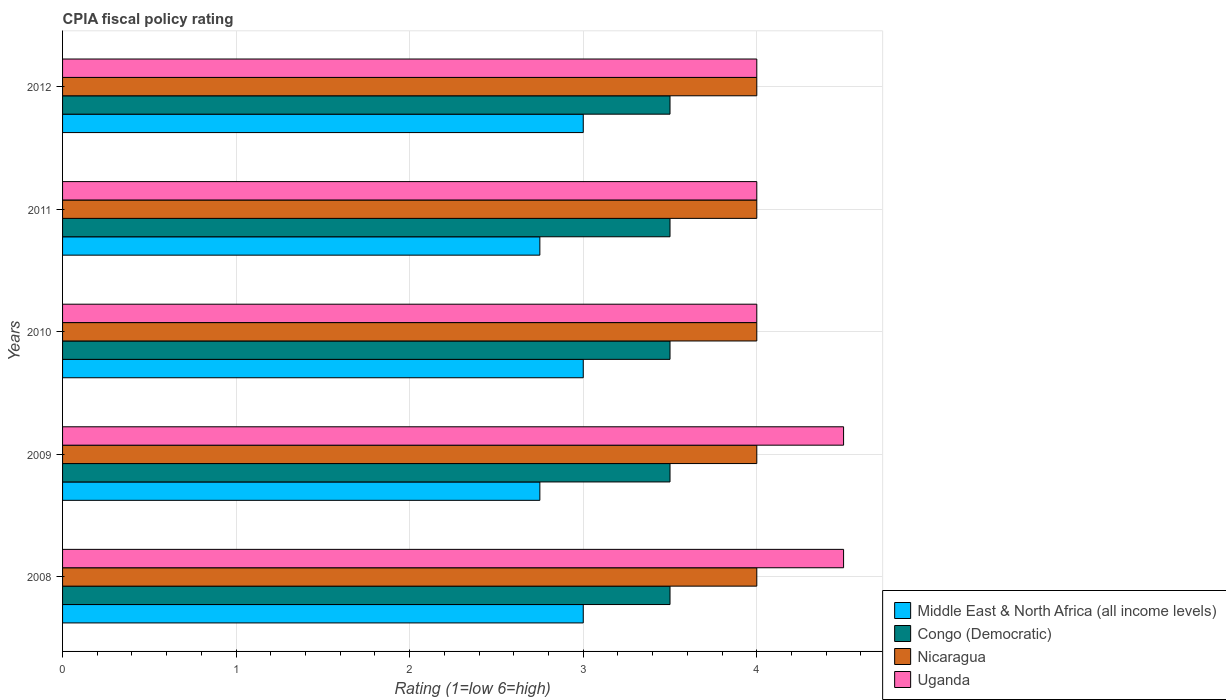How many different coloured bars are there?
Keep it short and to the point. 4. How many groups of bars are there?
Provide a succinct answer. 5. Are the number of bars per tick equal to the number of legend labels?
Keep it short and to the point. Yes. Are the number of bars on each tick of the Y-axis equal?
Your answer should be very brief. Yes. How many bars are there on the 5th tick from the top?
Make the answer very short. 4. What is the label of the 1st group of bars from the top?
Provide a short and direct response. 2012. What is the CPIA rating in Middle East & North Africa (all income levels) in 2009?
Make the answer very short. 2.75. Across all years, what is the maximum CPIA rating in Uganda?
Give a very brief answer. 4.5. What is the total CPIA rating in Nicaragua in the graph?
Your response must be concise. 20. What is the difference between the CPIA rating in Uganda in 2009 and that in 2012?
Your answer should be very brief. 0.5. What is the difference between the CPIA rating in Congo (Democratic) in 2011 and the CPIA rating in Nicaragua in 2008?
Provide a short and direct response. -0.5. What is the average CPIA rating in Middle East & North Africa (all income levels) per year?
Offer a terse response. 2.9. In the year 2010, what is the difference between the CPIA rating in Nicaragua and CPIA rating in Uganda?
Offer a terse response. 0. What is the ratio of the CPIA rating in Nicaragua in 2009 to that in 2012?
Provide a succinct answer. 1. What is the difference between the highest and the second highest CPIA rating in Uganda?
Your answer should be very brief. 0. What is the difference between the highest and the lowest CPIA rating in Uganda?
Your response must be concise. 0.5. What does the 2nd bar from the top in 2009 represents?
Give a very brief answer. Nicaragua. What does the 2nd bar from the bottom in 2008 represents?
Your response must be concise. Congo (Democratic). How many bars are there?
Give a very brief answer. 20. How many years are there in the graph?
Offer a very short reply. 5. Are the values on the major ticks of X-axis written in scientific E-notation?
Offer a very short reply. No. Does the graph contain any zero values?
Give a very brief answer. No. How are the legend labels stacked?
Your answer should be very brief. Vertical. What is the title of the graph?
Provide a short and direct response. CPIA fiscal policy rating. What is the Rating (1=low 6=high) in Congo (Democratic) in 2008?
Keep it short and to the point. 3.5. What is the Rating (1=low 6=high) of Nicaragua in 2008?
Your answer should be compact. 4. What is the Rating (1=low 6=high) in Uganda in 2008?
Make the answer very short. 4.5. What is the Rating (1=low 6=high) of Middle East & North Africa (all income levels) in 2009?
Provide a short and direct response. 2.75. What is the Rating (1=low 6=high) in Nicaragua in 2009?
Your answer should be very brief. 4. What is the Rating (1=low 6=high) of Uganda in 2009?
Provide a succinct answer. 4.5. What is the Rating (1=low 6=high) in Congo (Democratic) in 2010?
Provide a succinct answer. 3.5. What is the Rating (1=low 6=high) in Nicaragua in 2010?
Give a very brief answer. 4. What is the Rating (1=low 6=high) of Uganda in 2010?
Your answer should be compact. 4. What is the Rating (1=low 6=high) of Middle East & North Africa (all income levels) in 2011?
Offer a very short reply. 2.75. What is the Rating (1=low 6=high) in Congo (Democratic) in 2011?
Give a very brief answer. 3.5. What is the Rating (1=low 6=high) in Nicaragua in 2011?
Provide a succinct answer. 4. What is the Rating (1=low 6=high) of Congo (Democratic) in 2012?
Provide a succinct answer. 3.5. What is the Rating (1=low 6=high) in Nicaragua in 2012?
Your response must be concise. 4. Across all years, what is the minimum Rating (1=low 6=high) of Middle East & North Africa (all income levels)?
Provide a succinct answer. 2.75. Across all years, what is the minimum Rating (1=low 6=high) in Congo (Democratic)?
Give a very brief answer. 3.5. Across all years, what is the minimum Rating (1=low 6=high) of Nicaragua?
Offer a terse response. 4. Across all years, what is the minimum Rating (1=low 6=high) in Uganda?
Keep it short and to the point. 4. What is the total Rating (1=low 6=high) of Congo (Democratic) in the graph?
Provide a short and direct response. 17.5. What is the total Rating (1=low 6=high) in Nicaragua in the graph?
Your response must be concise. 20. What is the total Rating (1=low 6=high) in Uganda in the graph?
Your answer should be compact. 21. What is the difference between the Rating (1=low 6=high) in Nicaragua in 2008 and that in 2009?
Provide a short and direct response. 0. What is the difference between the Rating (1=low 6=high) in Uganda in 2008 and that in 2009?
Ensure brevity in your answer.  0. What is the difference between the Rating (1=low 6=high) of Congo (Democratic) in 2008 and that in 2010?
Your answer should be compact. 0. What is the difference between the Rating (1=low 6=high) of Middle East & North Africa (all income levels) in 2008 and that in 2011?
Keep it short and to the point. 0.25. What is the difference between the Rating (1=low 6=high) in Uganda in 2008 and that in 2011?
Give a very brief answer. 0.5. What is the difference between the Rating (1=low 6=high) in Congo (Democratic) in 2008 and that in 2012?
Ensure brevity in your answer.  0. What is the difference between the Rating (1=low 6=high) of Nicaragua in 2008 and that in 2012?
Offer a very short reply. 0. What is the difference between the Rating (1=low 6=high) of Middle East & North Africa (all income levels) in 2009 and that in 2010?
Your response must be concise. -0.25. What is the difference between the Rating (1=low 6=high) of Middle East & North Africa (all income levels) in 2009 and that in 2012?
Provide a short and direct response. -0.25. What is the difference between the Rating (1=low 6=high) in Nicaragua in 2009 and that in 2012?
Give a very brief answer. 0. What is the difference between the Rating (1=low 6=high) of Middle East & North Africa (all income levels) in 2010 and that in 2011?
Give a very brief answer. 0.25. What is the difference between the Rating (1=low 6=high) of Congo (Democratic) in 2010 and that in 2011?
Provide a short and direct response. 0. What is the difference between the Rating (1=low 6=high) of Nicaragua in 2010 and that in 2011?
Your answer should be very brief. 0. What is the difference between the Rating (1=low 6=high) of Uganda in 2010 and that in 2011?
Your answer should be very brief. 0. What is the difference between the Rating (1=low 6=high) of Nicaragua in 2010 and that in 2012?
Provide a succinct answer. 0. What is the difference between the Rating (1=low 6=high) of Uganda in 2010 and that in 2012?
Offer a terse response. 0. What is the difference between the Rating (1=low 6=high) in Uganda in 2011 and that in 2012?
Your response must be concise. 0. What is the difference between the Rating (1=low 6=high) of Middle East & North Africa (all income levels) in 2008 and the Rating (1=low 6=high) of Nicaragua in 2009?
Your answer should be compact. -1. What is the difference between the Rating (1=low 6=high) of Middle East & North Africa (all income levels) in 2008 and the Rating (1=low 6=high) of Uganda in 2009?
Your answer should be very brief. -1.5. What is the difference between the Rating (1=low 6=high) in Congo (Democratic) in 2008 and the Rating (1=low 6=high) in Nicaragua in 2009?
Provide a short and direct response. -0.5. What is the difference between the Rating (1=low 6=high) of Congo (Democratic) in 2008 and the Rating (1=low 6=high) of Uganda in 2009?
Offer a very short reply. -1. What is the difference between the Rating (1=low 6=high) in Middle East & North Africa (all income levels) in 2008 and the Rating (1=low 6=high) in Nicaragua in 2010?
Ensure brevity in your answer.  -1. What is the difference between the Rating (1=low 6=high) of Congo (Democratic) in 2008 and the Rating (1=low 6=high) of Uganda in 2010?
Your answer should be compact. -0.5. What is the difference between the Rating (1=low 6=high) of Nicaragua in 2008 and the Rating (1=low 6=high) of Uganda in 2010?
Your response must be concise. 0. What is the difference between the Rating (1=low 6=high) of Middle East & North Africa (all income levels) in 2008 and the Rating (1=low 6=high) of Uganda in 2011?
Keep it short and to the point. -1. What is the difference between the Rating (1=low 6=high) of Congo (Democratic) in 2008 and the Rating (1=low 6=high) of Uganda in 2011?
Your answer should be very brief. -0.5. What is the difference between the Rating (1=low 6=high) of Nicaragua in 2008 and the Rating (1=low 6=high) of Uganda in 2011?
Give a very brief answer. 0. What is the difference between the Rating (1=low 6=high) of Middle East & North Africa (all income levels) in 2008 and the Rating (1=low 6=high) of Congo (Democratic) in 2012?
Give a very brief answer. -0.5. What is the difference between the Rating (1=low 6=high) in Middle East & North Africa (all income levels) in 2008 and the Rating (1=low 6=high) in Nicaragua in 2012?
Offer a terse response. -1. What is the difference between the Rating (1=low 6=high) in Congo (Democratic) in 2008 and the Rating (1=low 6=high) in Uganda in 2012?
Keep it short and to the point. -0.5. What is the difference between the Rating (1=low 6=high) in Middle East & North Africa (all income levels) in 2009 and the Rating (1=low 6=high) in Congo (Democratic) in 2010?
Your answer should be very brief. -0.75. What is the difference between the Rating (1=low 6=high) in Middle East & North Africa (all income levels) in 2009 and the Rating (1=low 6=high) in Nicaragua in 2010?
Your answer should be very brief. -1.25. What is the difference between the Rating (1=low 6=high) of Middle East & North Africa (all income levels) in 2009 and the Rating (1=low 6=high) of Uganda in 2010?
Offer a very short reply. -1.25. What is the difference between the Rating (1=low 6=high) of Congo (Democratic) in 2009 and the Rating (1=low 6=high) of Nicaragua in 2010?
Give a very brief answer. -0.5. What is the difference between the Rating (1=low 6=high) of Nicaragua in 2009 and the Rating (1=low 6=high) of Uganda in 2010?
Your response must be concise. 0. What is the difference between the Rating (1=low 6=high) in Middle East & North Africa (all income levels) in 2009 and the Rating (1=low 6=high) in Congo (Democratic) in 2011?
Make the answer very short. -0.75. What is the difference between the Rating (1=low 6=high) of Middle East & North Africa (all income levels) in 2009 and the Rating (1=low 6=high) of Nicaragua in 2011?
Provide a succinct answer. -1.25. What is the difference between the Rating (1=low 6=high) of Middle East & North Africa (all income levels) in 2009 and the Rating (1=low 6=high) of Uganda in 2011?
Give a very brief answer. -1.25. What is the difference between the Rating (1=low 6=high) of Congo (Democratic) in 2009 and the Rating (1=low 6=high) of Nicaragua in 2011?
Your answer should be very brief. -0.5. What is the difference between the Rating (1=low 6=high) in Middle East & North Africa (all income levels) in 2009 and the Rating (1=low 6=high) in Congo (Democratic) in 2012?
Keep it short and to the point. -0.75. What is the difference between the Rating (1=low 6=high) of Middle East & North Africa (all income levels) in 2009 and the Rating (1=low 6=high) of Nicaragua in 2012?
Provide a short and direct response. -1.25. What is the difference between the Rating (1=low 6=high) in Middle East & North Africa (all income levels) in 2009 and the Rating (1=low 6=high) in Uganda in 2012?
Your answer should be compact. -1.25. What is the difference between the Rating (1=low 6=high) in Middle East & North Africa (all income levels) in 2010 and the Rating (1=low 6=high) in Nicaragua in 2011?
Keep it short and to the point. -1. What is the difference between the Rating (1=low 6=high) in Middle East & North Africa (all income levels) in 2010 and the Rating (1=low 6=high) in Uganda in 2011?
Make the answer very short. -1. What is the difference between the Rating (1=low 6=high) in Congo (Democratic) in 2010 and the Rating (1=low 6=high) in Nicaragua in 2011?
Your answer should be very brief. -0.5. What is the difference between the Rating (1=low 6=high) of Congo (Democratic) in 2010 and the Rating (1=low 6=high) of Uganda in 2011?
Your answer should be compact. -0.5. What is the difference between the Rating (1=low 6=high) of Nicaragua in 2010 and the Rating (1=low 6=high) of Uganda in 2011?
Provide a short and direct response. 0. What is the difference between the Rating (1=low 6=high) in Middle East & North Africa (all income levels) in 2010 and the Rating (1=low 6=high) in Congo (Democratic) in 2012?
Your response must be concise. -0.5. What is the difference between the Rating (1=low 6=high) in Middle East & North Africa (all income levels) in 2010 and the Rating (1=low 6=high) in Nicaragua in 2012?
Keep it short and to the point. -1. What is the difference between the Rating (1=low 6=high) in Congo (Democratic) in 2010 and the Rating (1=low 6=high) in Uganda in 2012?
Your answer should be compact. -0.5. What is the difference between the Rating (1=low 6=high) of Nicaragua in 2010 and the Rating (1=low 6=high) of Uganda in 2012?
Offer a terse response. 0. What is the difference between the Rating (1=low 6=high) in Middle East & North Africa (all income levels) in 2011 and the Rating (1=low 6=high) in Congo (Democratic) in 2012?
Ensure brevity in your answer.  -0.75. What is the difference between the Rating (1=low 6=high) of Middle East & North Africa (all income levels) in 2011 and the Rating (1=low 6=high) of Nicaragua in 2012?
Offer a very short reply. -1.25. What is the difference between the Rating (1=low 6=high) of Middle East & North Africa (all income levels) in 2011 and the Rating (1=low 6=high) of Uganda in 2012?
Make the answer very short. -1.25. What is the average Rating (1=low 6=high) in Uganda per year?
Offer a very short reply. 4.2. In the year 2008, what is the difference between the Rating (1=low 6=high) in Middle East & North Africa (all income levels) and Rating (1=low 6=high) in Uganda?
Your answer should be compact. -1.5. In the year 2008, what is the difference between the Rating (1=low 6=high) of Congo (Democratic) and Rating (1=low 6=high) of Uganda?
Keep it short and to the point. -1. In the year 2009, what is the difference between the Rating (1=low 6=high) of Middle East & North Africa (all income levels) and Rating (1=low 6=high) of Congo (Democratic)?
Offer a terse response. -0.75. In the year 2009, what is the difference between the Rating (1=low 6=high) in Middle East & North Africa (all income levels) and Rating (1=low 6=high) in Nicaragua?
Your answer should be very brief. -1.25. In the year 2009, what is the difference between the Rating (1=low 6=high) of Middle East & North Africa (all income levels) and Rating (1=low 6=high) of Uganda?
Your answer should be compact. -1.75. In the year 2009, what is the difference between the Rating (1=low 6=high) in Nicaragua and Rating (1=low 6=high) in Uganda?
Your response must be concise. -0.5. In the year 2010, what is the difference between the Rating (1=low 6=high) of Middle East & North Africa (all income levels) and Rating (1=low 6=high) of Nicaragua?
Provide a short and direct response. -1. In the year 2010, what is the difference between the Rating (1=low 6=high) in Middle East & North Africa (all income levels) and Rating (1=low 6=high) in Uganda?
Offer a terse response. -1. In the year 2010, what is the difference between the Rating (1=low 6=high) in Nicaragua and Rating (1=low 6=high) in Uganda?
Ensure brevity in your answer.  0. In the year 2011, what is the difference between the Rating (1=low 6=high) in Middle East & North Africa (all income levels) and Rating (1=low 6=high) in Congo (Democratic)?
Your answer should be compact. -0.75. In the year 2011, what is the difference between the Rating (1=low 6=high) of Middle East & North Africa (all income levels) and Rating (1=low 6=high) of Nicaragua?
Offer a very short reply. -1.25. In the year 2011, what is the difference between the Rating (1=low 6=high) of Middle East & North Africa (all income levels) and Rating (1=low 6=high) of Uganda?
Keep it short and to the point. -1.25. In the year 2011, what is the difference between the Rating (1=low 6=high) in Congo (Democratic) and Rating (1=low 6=high) in Nicaragua?
Ensure brevity in your answer.  -0.5. In the year 2011, what is the difference between the Rating (1=low 6=high) in Congo (Democratic) and Rating (1=low 6=high) in Uganda?
Your answer should be compact. -0.5. In the year 2012, what is the difference between the Rating (1=low 6=high) of Middle East & North Africa (all income levels) and Rating (1=low 6=high) of Nicaragua?
Provide a succinct answer. -1. In the year 2012, what is the difference between the Rating (1=low 6=high) of Middle East & North Africa (all income levels) and Rating (1=low 6=high) of Uganda?
Keep it short and to the point. -1. In the year 2012, what is the difference between the Rating (1=low 6=high) of Congo (Democratic) and Rating (1=low 6=high) of Nicaragua?
Your response must be concise. -0.5. In the year 2012, what is the difference between the Rating (1=low 6=high) of Congo (Democratic) and Rating (1=low 6=high) of Uganda?
Provide a short and direct response. -0.5. In the year 2012, what is the difference between the Rating (1=low 6=high) in Nicaragua and Rating (1=low 6=high) in Uganda?
Your answer should be compact. 0. What is the ratio of the Rating (1=low 6=high) of Congo (Democratic) in 2008 to that in 2009?
Give a very brief answer. 1. What is the ratio of the Rating (1=low 6=high) of Uganda in 2008 to that in 2009?
Your response must be concise. 1. What is the ratio of the Rating (1=low 6=high) of Middle East & North Africa (all income levels) in 2008 to that in 2010?
Give a very brief answer. 1. What is the ratio of the Rating (1=low 6=high) of Congo (Democratic) in 2008 to that in 2010?
Give a very brief answer. 1. What is the ratio of the Rating (1=low 6=high) in Nicaragua in 2008 to that in 2010?
Offer a terse response. 1. What is the ratio of the Rating (1=low 6=high) of Uganda in 2008 to that in 2010?
Your answer should be compact. 1.12. What is the ratio of the Rating (1=low 6=high) in Middle East & North Africa (all income levels) in 2008 to that in 2011?
Your response must be concise. 1.09. What is the ratio of the Rating (1=low 6=high) of Nicaragua in 2008 to that in 2011?
Provide a short and direct response. 1. What is the ratio of the Rating (1=low 6=high) of Uganda in 2008 to that in 2011?
Your answer should be very brief. 1.12. What is the ratio of the Rating (1=low 6=high) in Congo (Democratic) in 2008 to that in 2012?
Your answer should be very brief. 1. What is the ratio of the Rating (1=low 6=high) in Nicaragua in 2008 to that in 2012?
Your answer should be very brief. 1. What is the ratio of the Rating (1=low 6=high) in Congo (Democratic) in 2009 to that in 2010?
Provide a succinct answer. 1. What is the ratio of the Rating (1=low 6=high) of Uganda in 2009 to that in 2010?
Make the answer very short. 1.12. What is the ratio of the Rating (1=low 6=high) of Uganda in 2009 to that in 2011?
Make the answer very short. 1.12. What is the ratio of the Rating (1=low 6=high) in Congo (Democratic) in 2009 to that in 2012?
Provide a succinct answer. 1. What is the ratio of the Rating (1=low 6=high) in Nicaragua in 2009 to that in 2012?
Ensure brevity in your answer.  1. What is the ratio of the Rating (1=low 6=high) of Uganda in 2009 to that in 2012?
Your answer should be compact. 1.12. What is the ratio of the Rating (1=low 6=high) of Congo (Democratic) in 2010 to that in 2011?
Your response must be concise. 1. What is the ratio of the Rating (1=low 6=high) in Middle East & North Africa (all income levels) in 2010 to that in 2012?
Provide a short and direct response. 1. What is the ratio of the Rating (1=low 6=high) of Congo (Democratic) in 2010 to that in 2012?
Provide a short and direct response. 1. What is the ratio of the Rating (1=low 6=high) of Uganda in 2010 to that in 2012?
Your answer should be compact. 1. What is the ratio of the Rating (1=low 6=high) in Middle East & North Africa (all income levels) in 2011 to that in 2012?
Offer a terse response. 0.92. What is the ratio of the Rating (1=low 6=high) of Uganda in 2011 to that in 2012?
Make the answer very short. 1. What is the difference between the highest and the second highest Rating (1=low 6=high) of Middle East & North Africa (all income levels)?
Keep it short and to the point. 0. What is the difference between the highest and the lowest Rating (1=low 6=high) in Congo (Democratic)?
Your answer should be very brief. 0. What is the difference between the highest and the lowest Rating (1=low 6=high) of Nicaragua?
Make the answer very short. 0. 